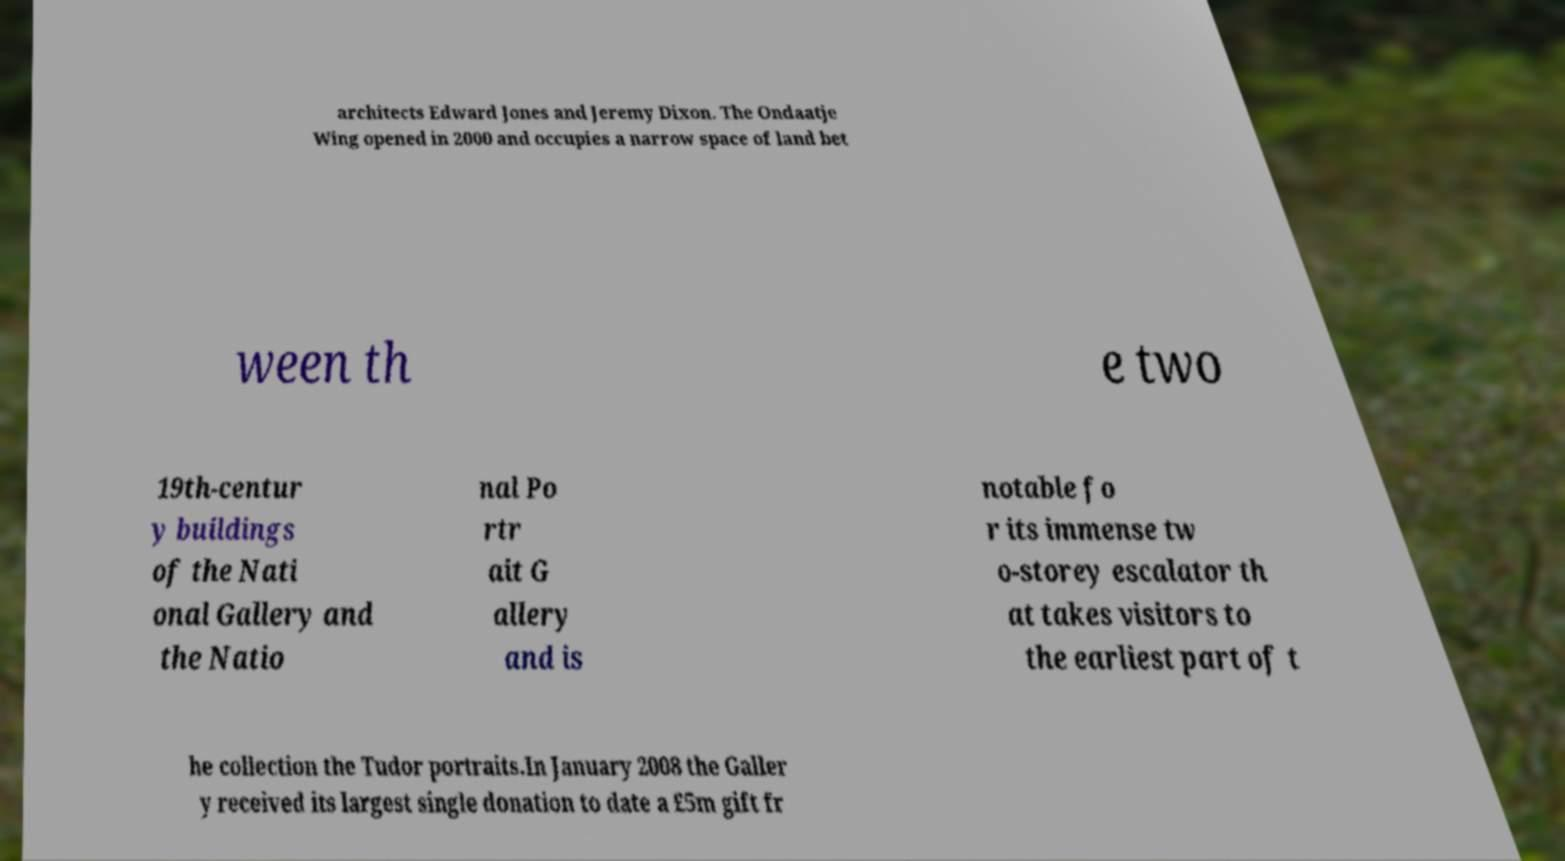Please identify and transcribe the text found in this image. architects Edward Jones and Jeremy Dixon. The Ondaatje Wing opened in 2000 and occupies a narrow space of land bet ween th e two 19th-centur y buildings of the Nati onal Gallery and the Natio nal Po rtr ait G allery and is notable fo r its immense tw o-storey escalator th at takes visitors to the earliest part of t he collection the Tudor portraits.In January 2008 the Galler y received its largest single donation to date a £5m gift fr 